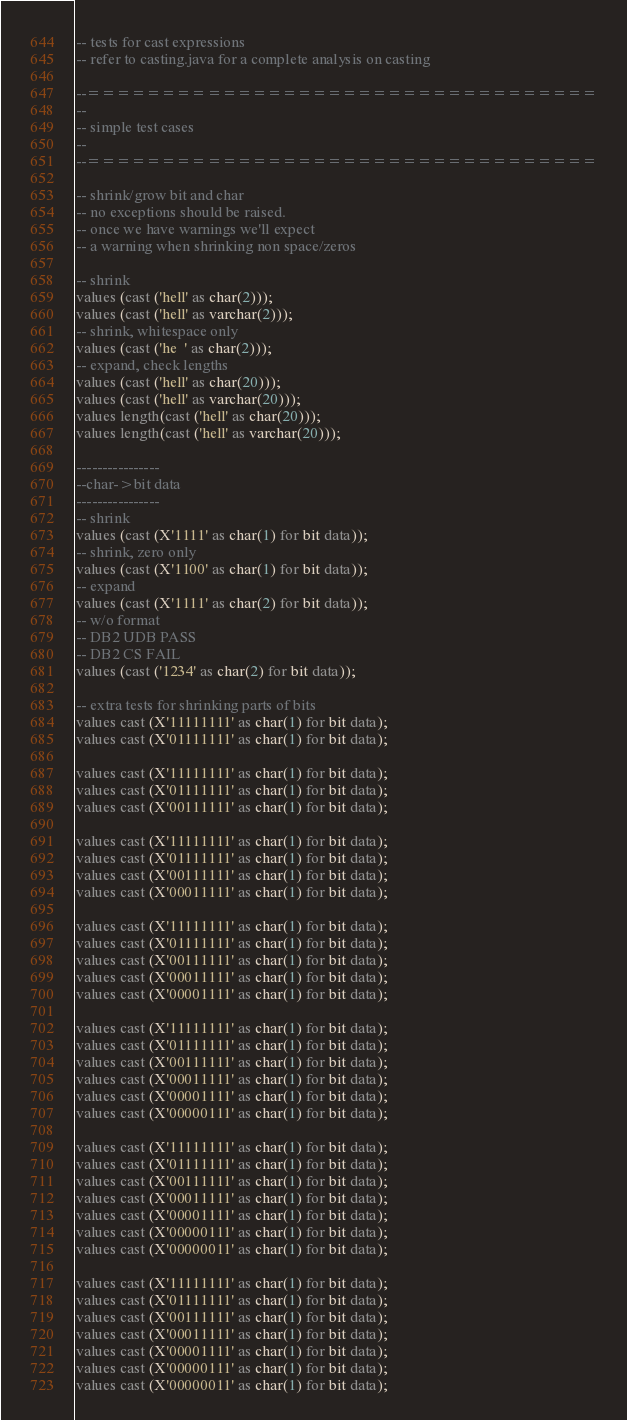<code> <loc_0><loc_0><loc_500><loc_500><_SQL_>-- tests for cast expressions
-- refer to casting.java for a complete analysis on casting

--==================================
--
-- simple test cases
--
--==================================

-- shrink/grow bit and char
-- no exceptions should be raised.
-- once we have warnings we'll expect
-- a warning when shrinking non space/zeros

-- shrink
values (cast ('hell' as char(2)));
values (cast ('hell' as varchar(2)));
-- shrink, whitespace only
values (cast ('he  ' as char(2)));
-- expand, check lengths
values (cast ('hell' as char(20))); 
values (cast ('hell' as varchar(20))); 
values length(cast ('hell' as char(20)));
values length(cast ('hell' as varchar(20)));

----------------
--char->bit data
----------------
-- shrink
values (cast (X'1111' as char(1) for bit data));
-- shrink, zero only
values (cast (X'1100' as char(1) for bit data));
-- expand
values (cast (X'1111' as char(2) for bit data));
-- w/o format
-- DB2 UDB PASS
-- DB2 CS FAIL
values (cast ('1234' as char(2) for bit data));

-- extra tests for shrinking parts of bits
values cast (X'11111111' as char(1) for bit data);
values cast (X'01111111' as char(1) for bit data);

values cast (X'11111111' as char(1) for bit data);
values cast (X'01111111' as char(1) for bit data);
values cast (X'00111111' as char(1) for bit data);

values cast (X'11111111' as char(1) for bit data);
values cast (X'01111111' as char(1) for bit data);
values cast (X'00111111' as char(1) for bit data);
values cast (X'00011111' as char(1) for bit data);

values cast (X'11111111' as char(1) for bit data);
values cast (X'01111111' as char(1) for bit data);
values cast (X'00111111' as char(1) for bit data);
values cast (X'00011111' as char(1) for bit data);
values cast (X'00001111' as char(1) for bit data);

values cast (X'11111111' as char(1) for bit data);
values cast (X'01111111' as char(1) for bit data);
values cast (X'00111111' as char(1) for bit data);
values cast (X'00011111' as char(1) for bit data);
values cast (X'00001111' as char(1) for bit data);
values cast (X'00000111' as char(1) for bit data);

values cast (X'11111111' as char(1) for bit data);
values cast (X'01111111' as char(1) for bit data);
values cast (X'00111111' as char(1) for bit data);
values cast (X'00011111' as char(1) for bit data);
values cast (X'00001111' as char(1) for bit data);
values cast (X'00000111' as char(1) for bit data);
values cast (X'00000011' as char(1) for bit data);

values cast (X'11111111' as char(1) for bit data);
values cast (X'01111111' as char(1) for bit data);
values cast (X'00111111' as char(1) for bit data);
values cast (X'00011111' as char(1) for bit data);
values cast (X'00001111' as char(1) for bit data);
values cast (X'00000111' as char(1) for bit data);
values cast (X'00000011' as char(1) for bit data);</code> 